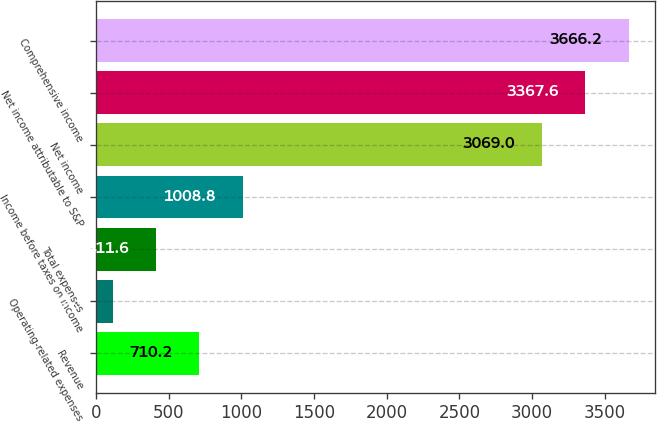<chart> <loc_0><loc_0><loc_500><loc_500><bar_chart><fcel>Revenue<fcel>Operating-related expenses<fcel>Total expenses<fcel>Income before taxes on income<fcel>Net income<fcel>Net income attributable to S&P<fcel>Comprehensive income<nl><fcel>710.2<fcel>113<fcel>411.6<fcel>1008.8<fcel>3069<fcel>3367.6<fcel>3666.2<nl></chart> 